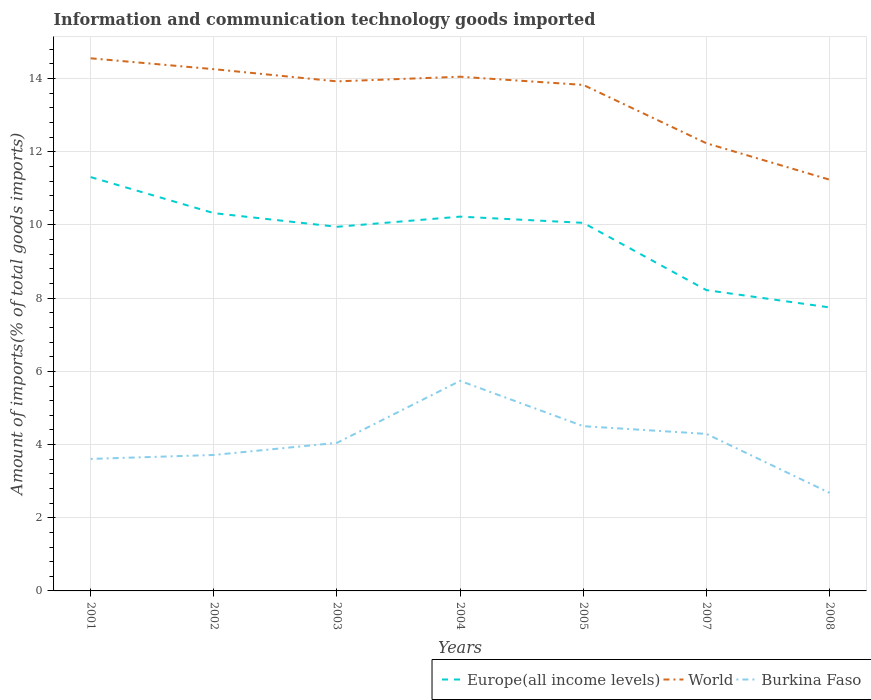Does the line corresponding to Burkina Faso intersect with the line corresponding to World?
Provide a short and direct response. No. Is the number of lines equal to the number of legend labels?
Give a very brief answer. Yes. Across all years, what is the maximum amount of goods imported in World?
Your response must be concise. 11.24. In which year was the amount of goods imported in Europe(all income levels) maximum?
Provide a succinct answer. 2008. What is the total amount of goods imported in Burkina Faso in the graph?
Provide a succinct answer. -0.33. What is the difference between the highest and the second highest amount of goods imported in World?
Offer a very short reply. 3.32. How many years are there in the graph?
Keep it short and to the point. 7. What is the difference between two consecutive major ticks on the Y-axis?
Keep it short and to the point. 2. Are the values on the major ticks of Y-axis written in scientific E-notation?
Offer a very short reply. No. Does the graph contain any zero values?
Your answer should be very brief. No. Where does the legend appear in the graph?
Ensure brevity in your answer.  Bottom right. What is the title of the graph?
Give a very brief answer. Information and communication technology goods imported. Does "Rwanda" appear as one of the legend labels in the graph?
Keep it short and to the point. No. What is the label or title of the Y-axis?
Your response must be concise. Amount of imports(% of total goods imports). What is the Amount of imports(% of total goods imports) of Europe(all income levels) in 2001?
Your answer should be very brief. 11.31. What is the Amount of imports(% of total goods imports) of World in 2001?
Offer a very short reply. 14.56. What is the Amount of imports(% of total goods imports) in Burkina Faso in 2001?
Your response must be concise. 3.61. What is the Amount of imports(% of total goods imports) in Europe(all income levels) in 2002?
Provide a succinct answer. 10.32. What is the Amount of imports(% of total goods imports) of World in 2002?
Make the answer very short. 14.26. What is the Amount of imports(% of total goods imports) of Burkina Faso in 2002?
Provide a succinct answer. 3.72. What is the Amount of imports(% of total goods imports) of Europe(all income levels) in 2003?
Offer a very short reply. 9.95. What is the Amount of imports(% of total goods imports) in World in 2003?
Offer a terse response. 13.92. What is the Amount of imports(% of total goods imports) of Burkina Faso in 2003?
Provide a succinct answer. 4.05. What is the Amount of imports(% of total goods imports) of Europe(all income levels) in 2004?
Keep it short and to the point. 10.23. What is the Amount of imports(% of total goods imports) of World in 2004?
Offer a very short reply. 14.05. What is the Amount of imports(% of total goods imports) of Burkina Faso in 2004?
Your response must be concise. 5.74. What is the Amount of imports(% of total goods imports) of Europe(all income levels) in 2005?
Offer a very short reply. 10.06. What is the Amount of imports(% of total goods imports) of World in 2005?
Provide a short and direct response. 13.83. What is the Amount of imports(% of total goods imports) of Burkina Faso in 2005?
Ensure brevity in your answer.  4.5. What is the Amount of imports(% of total goods imports) of Europe(all income levels) in 2007?
Offer a very short reply. 8.22. What is the Amount of imports(% of total goods imports) in World in 2007?
Ensure brevity in your answer.  12.23. What is the Amount of imports(% of total goods imports) of Burkina Faso in 2007?
Provide a short and direct response. 4.29. What is the Amount of imports(% of total goods imports) of Europe(all income levels) in 2008?
Make the answer very short. 7.75. What is the Amount of imports(% of total goods imports) of World in 2008?
Make the answer very short. 11.24. What is the Amount of imports(% of total goods imports) of Burkina Faso in 2008?
Your answer should be compact. 2.68. Across all years, what is the maximum Amount of imports(% of total goods imports) in Europe(all income levels)?
Your answer should be very brief. 11.31. Across all years, what is the maximum Amount of imports(% of total goods imports) of World?
Your answer should be very brief. 14.56. Across all years, what is the maximum Amount of imports(% of total goods imports) of Burkina Faso?
Your answer should be compact. 5.74. Across all years, what is the minimum Amount of imports(% of total goods imports) in Europe(all income levels)?
Keep it short and to the point. 7.75. Across all years, what is the minimum Amount of imports(% of total goods imports) in World?
Keep it short and to the point. 11.24. Across all years, what is the minimum Amount of imports(% of total goods imports) in Burkina Faso?
Offer a terse response. 2.68. What is the total Amount of imports(% of total goods imports) of Europe(all income levels) in the graph?
Your response must be concise. 67.84. What is the total Amount of imports(% of total goods imports) in World in the graph?
Make the answer very short. 94.09. What is the total Amount of imports(% of total goods imports) of Burkina Faso in the graph?
Offer a terse response. 28.58. What is the difference between the Amount of imports(% of total goods imports) in Europe(all income levels) in 2001 and that in 2002?
Make the answer very short. 0.98. What is the difference between the Amount of imports(% of total goods imports) of World in 2001 and that in 2002?
Your answer should be compact. 0.3. What is the difference between the Amount of imports(% of total goods imports) of Burkina Faso in 2001 and that in 2002?
Your response must be concise. -0.11. What is the difference between the Amount of imports(% of total goods imports) of Europe(all income levels) in 2001 and that in 2003?
Ensure brevity in your answer.  1.36. What is the difference between the Amount of imports(% of total goods imports) in World in 2001 and that in 2003?
Your answer should be very brief. 0.63. What is the difference between the Amount of imports(% of total goods imports) of Burkina Faso in 2001 and that in 2003?
Ensure brevity in your answer.  -0.44. What is the difference between the Amount of imports(% of total goods imports) in Europe(all income levels) in 2001 and that in 2004?
Ensure brevity in your answer.  1.08. What is the difference between the Amount of imports(% of total goods imports) of World in 2001 and that in 2004?
Keep it short and to the point. 0.5. What is the difference between the Amount of imports(% of total goods imports) of Burkina Faso in 2001 and that in 2004?
Offer a very short reply. -2.13. What is the difference between the Amount of imports(% of total goods imports) in Europe(all income levels) in 2001 and that in 2005?
Provide a short and direct response. 1.25. What is the difference between the Amount of imports(% of total goods imports) in World in 2001 and that in 2005?
Provide a succinct answer. 0.73. What is the difference between the Amount of imports(% of total goods imports) in Burkina Faso in 2001 and that in 2005?
Your response must be concise. -0.9. What is the difference between the Amount of imports(% of total goods imports) in Europe(all income levels) in 2001 and that in 2007?
Keep it short and to the point. 3.09. What is the difference between the Amount of imports(% of total goods imports) of World in 2001 and that in 2007?
Your answer should be compact. 2.32. What is the difference between the Amount of imports(% of total goods imports) of Burkina Faso in 2001 and that in 2007?
Provide a succinct answer. -0.68. What is the difference between the Amount of imports(% of total goods imports) in Europe(all income levels) in 2001 and that in 2008?
Make the answer very short. 3.56. What is the difference between the Amount of imports(% of total goods imports) in World in 2001 and that in 2008?
Your answer should be very brief. 3.32. What is the difference between the Amount of imports(% of total goods imports) in Burkina Faso in 2001 and that in 2008?
Make the answer very short. 0.93. What is the difference between the Amount of imports(% of total goods imports) in Europe(all income levels) in 2002 and that in 2003?
Your response must be concise. 0.37. What is the difference between the Amount of imports(% of total goods imports) of World in 2002 and that in 2003?
Your answer should be very brief. 0.33. What is the difference between the Amount of imports(% of total goods imports) in Burkina Faso in 2002 and that in 2003?
Keep it short and to the point. -0.33. What is the difference between the Amount of imports(% of total goods imports) in Europe(all income levels) in 2002 and that in 2004?
Keep it short and to the point. 0.1. What is the difference between the Amount of imports(% of total goods imports) in World in 2002 and that in 2004?
Give a very brief answer. 0.21. What is the difference between the Amount of imports(% of total goods imports) in Burkina Faso in 2002 and that in 2004?
Keep it short and to the point. -2.03. What is the difference between the Amount of imports(% of total goods imports) in Europe(all income levels) in 2002 and that in 2005?
Make the answer very short. 0.27. What is the difference between the Amount of imports(% of total goods imports) in World in 2002 and that in 2005?
Your answer should be very brief. 0.43. What is the difference between the Amount of imports(% of total goods imports) in Burkina Faso in 2002 and that in 2005?
Ensure brevity in your answer.  -0.79. What is the difference between the Amount of imports(% of total goods imports) in Europe(all income levels) in 2002 and that in 2007?
Your response must be concise. 2.1. What is the difference between the Amount of imports(% of total goods imports) in World in 2002 and that in 2007?
Offer a very short reply. 2.02. What is the difference between the Amount of imports(% of total goods imports) in Burkina Faso in 2002 and that in 2007?
Your answer should be very brief. -0.58. What is the difference between the Amount of imports(% of total goods imports) of Europe(all income levels) in 2002 and that in 2008?
Provide a succinct answer. 2.58. What is the difference between the Amount of imports(% of total goods imports) in World in 2002 and that in 2008?
Offer a very short reply. 3.02. What is the difference between the Amount of imports(% of total goods imports) of Burkina Faso in 2002 and that in 2008?
Ensure brevity in your answer.  1.04. What is the difference between the Amount of imports(% of total goods imports) of Europe(all income levels) in 2003 and that in 2004?
Keep it short and to the point. -0.28. What is the difference between the Amount of imports(% of total goods imports) of World in 2003 and that in 2004?
Offer a very short reply. -0.13. What is the difference between the Amount of imports(% of total goods imports) of Burkina Faso in 2003 and that in 2004?
Your answer should be compact. -1.69. What is the difference between the Amount of imports(% of total goods imports) of Europe(all income levels) in 2003 and that in 2005?
Provide a short and direct response. -0.11. What is the difference between the Amount of imports(% of total goods imports) of World in 2003 and that in 2005?
Ensure brevity in your answer.  0.1. What is the difference between the Amount of imports(% of total goods imports) of Burkina Faso in 2003 and that in 2005?
Offer a very short reply. -0.46. What is the difference between the Amount of imports(% of total goods imports) in Europe(all income levels) in 2003 and that in 2007?
Provide a short and direct response. 1.73. What is the difference between the Amount of imports(% of total goods imports) in World in 2003 and that in 2007?
Provide a short and direct response. 1.69. What is the difference between the Amount of imports(% of total goods imports) of Burkina Faso in 2003 and that in 2007?
Offer a terse response. -0.24. What is the difference between the Amount of imports(% of total goods imports) of Europe(all income levels) in 2003 and that in 2008?
Provide a succinct answer. 2.2. What is the difference between the Amount of imports(% of total goods imports) in World in 2003 and that in 2008?
Provide a succinct answer. 2.69. What is the difference between the Amount of imports(% of total goods imports) of Burkina Faso in 2003 and that in 2008?
Give a very brief answer. 1.37. What is the difference between the Amount of imports(% of total goods imports) of Europe(all income levels) in 2004 and that in 2005?
Ensure brevity in your answer.  0.17. What is the difference between the Amount of imports(% of total goods imports) of World in 2004 and that in 2005?
Provide a short and direct response. 0.22. What is the difference between the Amount of imports(% of total goods imports) of Burkina Faso in 2004 and that in 2005?
Your response must be concise. 1.24. What is the difference between the Amount of imports(% of total goods imports) of Europe(all income levels) in 2004 and that in 2007?
Your answer should be compact. 2.01. What is the difference between the Amount of imports(% of total goods imports) in World in 2004 and that in 2007?
Provide a short and direct response. 1.82. What is the difference between the Amount of imports(% of total goods imports) in Burkina Faso in 2004 and that in 2007?
Ensure brevity in your answer.  1.45. What is the difference between the Amount of imports(% of total goods imports) in Europe(all income levels) in 2004 and that in 2008?
Offer a terse response. 2.48. What is the difference between the Amount of imports(% of total goods imports) of World in 2004 and that in 2008?
Keep it short and to the point. 2.81. What is the difference between the Amount of imports(% of total goods imports) in Burkina Faso in 2004 and that in 2008?
Your answer should be very brief. 3.06. What is the difference between the Amount of imports(% of total goods imports) of Europe(all income levels) in 2005 and that in 2007?
Ensure brevity in your answer.  1.84. What is the difference between the Amount of imports(% of total goods imports) of World in 2005 and that in 2007?
Provide a short and direct response. 1.59. What is the difference between the Amount of imports(% of total goods imports) of Burkina Faso in 2005 and that in 2007?
Offer a terse response. 0.21. What is the difference between the Amount of imports(% of total goods imports) in Europe(all income levels) in 2005 and that in 2008?
Give a very brief answer. 2.31. What is the difference between the Amount of imports(% of total goods imports) of World in 2005 and that in 2008?
Provide a succinct answer. 2.59. What is the difference between the Amount of imports(% of total goods imports) of Burkina Faso in 2005 and that in 2008?
Offer a very short reply. 1.82. What is the difference between the Amount of imports(% of total goods imports) in Europe(all income levels) in 2007 and that in 2008?
Ensure brevity in your answer.  0.47. What is the difference between the Amount of imports(% of total goods imports) in World in 2007 and that in 2008?
Offer a very short reply. 0.99. What is the difference between the Amount of imports(% of total goods imports) in Burkina Faso in 2007 and that in 2008?
Your answer should be very brief. 1.61. What is the difference between the Amount of imports(% of total goods imports) of Europe(all income levels) in 2001 and the Amount of imports(% of total goods imports) of World in 2002?
Provide a succinct answer. -2.95. What is the difference between the Amount of imports(% of total goods imports) of Europe(all income levels) in 2001 and the Amount of imports(% of total goods imports) of Burkina Faso in 2002?
Ensure brevity in your answer.  7.59. What is the difference between the Amount of imports(% of total goods imports) in World in 2001 and the Amount of imports(% of total goods imports) in Burkina Faso in 2002?
Provide a succinct answer. 10.84. What is the difference between the Amount of imports(% of total goods imports) of Europe(all income levels) in 2001 and the Amount of imports(% of total goods imports) of World in 2003?
Give a very brief answer. -2.62. What is the difference between the Amount of imports(% of total goods imports) in Europe(all income levels) in 2001 and the Amount of imports(% of total goods imports) in Burkina Faso in 2003?
Ensure brevity in your answer.  7.26. What is the difference between the Amount of imports(% of total goods imports) of World in 2001 and the Amount of imports(% of total goods imports) of Burkina Faso in 2003?
Offer a very short reply. 10.51. What is the difference between the Amount of imports(% of total goods imports) of Europe(all income levels) in 2001 and the Amount of imports(% of total goods imports) of World in 2004?
Your answer should be very brief. -2.74. What is the difference between the Amount of imports(% of total goods imports) in Europe(all income levels) in 2001 and the Amount of imports(% of total goods imports) in Burkina Faso in 2004?
Your response must be concise. 5.57. What is the difference between the Amount of imports(% of total goods imports) of World in 2001 and the Amount of imports(% of total goods imports) of Burkina Faso in 2004?
Offer a terse response. 8.81. What is the difference between the Amount of imports(% of total goods imports) of Europe(all income levels) in 2001 and the Amount of imports(% of total goods imports) of World in 2005?
Your response must be concise. -2.52. What is the difference between the Amount of imports(% of total goods imports) of Europe(all income levels) in 2001 and the Amount of imports(% of total goods imports) of Burkina Faso in 2005?
Your answer should be very brief. 6.81. What is the difference between the Amount of imports(% of total goods imports) of World in 2001 and the Amount of imports(% of total goods imports) of Burkina Faso in 2005?
Offer a terse response. 10.05. What is the difference between the Amount of imports(% of total goods imports) in Europe(all income levels) in 2001 and the Amount of imports(% of total goods imports) in World in 2007?
Offer a very short reply. -0.92. What is the difference between the Amount of imports(% of total goods imports) of Europe(all income levels) in 2001 and the Amount of imports(% of total goods imports) of Burkina Faso in 2007?
Make the answer very short. 7.02. What is the difference between the Amount of imports(% of total goods imports) of World in 2001 and the Amount of imports(% of total goods imports) of Burkina Faso in 2007?
Your answer should be very brief. 10.26. What is the difference between the Amount of imports(% of total goods imports) of Europe(all income levels) in 2001 and the Amount of imports(% of total goods imports) of World in 2008?
Give a very brief answer. 0.07. What is the difference between the Amount of imports(% of total goods imports) of Europe(all income levels) in 2001 and the Amount of imports(% of total goods imports) of Burkina Faso in 2008?
Your answer should be compact. 8.63. What is the difference between the Amount of imports(% of total goods imports) in World in 2001 and the Amount of imports(% of total goods imports) in Burkina Faso in 2008?
Make the answer very short. 11.88. What is the difference between the Amount of imports(% of total goods imports) of Europe(all income levels) in 2002 and the Amount of imports(% of total goods imports) of World in 2003?
Ensure brevity in your answer.  -3.6. What is the difference between the Amount of imports(% of total goods imports) of Europe(all income levels) in 2002 and the Amount of imports(% of total goods imports) of Burkina Faso in 2003?
Provide a succinct answer. 6.28. What is the difference between the Amount of imports(% of total goods imports) of World in 2002 and the Amount of imports(% of total goods imports) of Burkina Faso in 2003?
Give a very brief answer. 10.21. What is the difference between the Amount of imports(% of total goods imports) in Europe(all income levels) in 2002 and the Amount of imports(% of total goods imports) in World in 2004?
Ensure brevity in your answer.  -3.73. What is the difference between the Amount of imports(% of total goods imports) in Europe(all income levels) in 2002 and the Amount of imports(% of total goods imports) in Burkina Faso in 2004?
Make the answer very short. 4.58. What is the difference between the Amount of imports(% of total goods imports) of World in 2002 and the Amount of imports(% of total goods imports) of Burkina Faso in 2004?
Make the answer very short. 8.52. What is the difference between the Amount of imports(% of total goods imports) of Europe(all income levels) in 2002 and the Amount of imports(% of total goods imports) of World in 2005?
Make the answer very short. -3.5. What is the difference between the Amount of imports(% of total goods imports) of Europe(all income levels) in 2002 and the Amount of imports(% of total goods imports) of Burkina Faso in 2005?
Provide a succinct answer. 5.82. What is the difference between the Amount of imports(% of total goods imports) of World in 2002 and the Amount of imports(% of total goods imports) of Burkina Faso in 2005?
Keep it short and to the point. 9.76. What is the difference between the Amount of imports(% of total goods imports) of Europe(all income levels) in 2002 and the Amount of imports(% of total goods imports) of World in 2007?
Keep it short and to the point. -1.91. What is the difference between the Amount of imports(% of total goods imports) of Europe(all income levels) in 2002 and the Amount of imports(% of total goods imports) of Burkina Faso in 2007?
Offer a terse response. 6.03. What is the difference between the Amount of imports(% of total goods imports) in World in 2002 and the Amount of imports(% of total goods imports) in Burkina Faso in 2007?
Provide a succinct answer. 9.97. What is the difference between the Amount of imports(% of total goods imports) of Europe(all income levels) in 2002 and the Amount of imports(% of total goods imports) of World in 2008?
Provide a short and direct response. -0.91. What is the difference between the Amount of imports(% of total goods imports) of Europe(all income levels) in 2002 and the Amount of imports(% of total goods imports) of Burkina Faso in 2008?
Your response must be concise. 7.64. What is the difference between the Amount of imports(% of total goods imports) of World in 2002 and the Amount of imports(% of total goods imports) of Burkina Faso in 2008?
Give a very brief answer. 11.58. What is the difference between the Amount of imports(% of total goods imports) of Europe(all income levels) in 2003 and the Amount of imports(% of total goods imports) of World in 2004?
Make the answer very short. -4.1. What is the difference between the Amount of imports(% of total goods imports) in Europe(all income levels) in 2003 and the Amount of imports(% of total goods imports) in Burkina Faso in 2004?
Ensure brevity in your answer.  4.21. What is the difference between the Amount of imports(% of total goods imports) of World in 2003 and the Amount of imports(% of total goods imports) of Burkina Faso in 2004?
Keep it short and to the point. 8.18. What is the difference between the Amount of imports(% of total goods imports) of Europe(all income levels) in 2003 and the Amount of imports(% of total goods imports) of World in 2005?
Provide a short and direct response. -3.88. What is the difference between the Amount of imports(% of total goods imports) in Europe(all income levels) in 2003 and the Amount of imports(% of total goods imports) in Burkina Faso in 2005?
Offer a very short reply. 5.45. What is the difference between the Amount of imports(% of total goods imports) of World in 2003 and the Amount of imports(% of total goods imports) of Burkina Faso in 2005?
Provide a short and direct response. 9.42. What is the difference between the Amount of imports(% of total goods imports) of Europe(all income levels) in 2003 and the Amount of imports(% of total goods imports) of World in 2007?
Provide a short and direct response. -2.28. What is the difference between the Amount of imports(% of total goods imports) in Europe(all income levels) in 2003 and the Amount of imports(% of total goods imports) in Burkina Faso in 2007?
Offer a very short reply. 5.66. What is the difference between the Amount of imports(% of total goods imports) in World in 2003 and the Amount of imports(% of total goods imports) in Burkina Faso in 2007?
Your answer should be compact. 9.63. What is the difference between the Amount of imports(% of total goods imports) of Europe(all income levels) in 2003 and the Amount of imports(% of total goods imports) of World in 2008?
Offer a very short reply. -1.29. What is the difference between the Amount of imports(% of total goods imports) in Europe(all income levels) in 2003 and the Amount of imports(% of total goods imports) in Burkina Faso in 2008?
Your response must be concise. 7.27. What is the difference between the Amount of imports(% of total goods imports) of World in 2003 and the Amount of imports(% of total goods imports) of Burkina Faso in 2008?
Offer a very short reply. 11.24. What is the difference between the Amount of imports(% of total goods imports) of Europe(all income levels) in 2004 and the Amount of imports(% of total goods imports) of World in 2005?
Provide a succinct answer. -3.6. What is the difference between the Amount of imports(% of total goods imports) in Europe(all income levels) in 2004 and the Amount of imports(% of total goods imports) in Burkina Faso in 2005?
Your answer should be compact. 5.73. What is the difference between the Amount of imports(% of total goods imports) in World in 2004 and the Amount of imports(% of total goods imports) in Burkina Faso in 2005?
Offer a terse response. 9.55. What is the difference between the Amount of imports(% of total goods imports) in Europe(all income levels) in 2004 and the Amount of imports(% of total goods imports) in World in 2007?
Your answer should be very brief. -2. What is the difference between the Amount of imports(% of total goods imports) in Europe(all income levels) in 2004 and the Amount of imports(% of total goods imports) in Burkina Faso in 2007?
Ensure brevity in your answer.  5.94. What is the difference between the Amount of imports(% of total goods imports) of World in 2004 and the Amount of imports(% of total goods imports) of Burkina Faso in 2007?
Your answer should be very brief. 9.76. What is the difference between the Amount of imports(% of total goods imports) in Europe(all income levels) in 2004 and the Amount of imports(% of total goods imports) in World in 2008?
Keep it short and to the point. -1.01. What is the difference between the Amount of imports(% of total goods imports) in Europe(all income levels) in 2004 and the Amount of imports(% of total goods imports) in Burkina Faso in 2008?
Keep it short and to the point. 7.55. What is the difference between the Amount of imports(% of total goods imports) in World in 2004 and the Amount of imports(% of total goods imports) in Burkina Faso in 2008?
Ensure brevity in your answer.  11.37. What is the difference between the Amount of imports(% of total goods imports) of Europe(all income levels) in 2005 and the Amount of imports(% of total goods imports) of World in 2007?
Provide a short and direct response. -2.17. What is the difference between the Amount of imports(% of total goods imports) in Europe(all income levels) in 2005 and the Amount of imports(% of total goods imports) in Burkina Faso in 2007?
Provide a succinct answer. 5.77. What is the difference between the Amount of imports(% of total goods imports) of World in 2005 and the Amount of imports(% of total goods imports) of Burkina Faso in 2007?
Keep it short and to the point. 9.54. What is the difference between the Amount of imports(% of total goods imports) of Europe(all income levels) in 2005 and the Amount of imports(% of total goods imports) of World in 2008?
Ensure brevity in your answer.  -1.18. What is the difference between the Amount of imports(% of total goods imports) in Europe(all income levels) in 2005 and the Amount of imports(% of total goods imports) in Burkina Faso in 2008?
Ensure brevity in your answer.  7.38. What is the difference between the Amount of imports(% of total goods imports) of World in 2005 and the Amount of imports(% of total goods imports) of Burkina Faso in 2008?
Make the answer very short. 11.15. What is the difference between the Amount of imports(% of total goods imports) in Europe(all income levels) in 2007 and the Amount of imports(% of total goods imports) in World in 2008?
Provide a short and direct response. -3.02. What is the difference between the Amount of imports(% of total goods imports) in Europe(all income levels) in 2007 and the Amount of imports(% of total goods imports) in Burkina Faso in 2008?
Keep it short and to the point. 5.54. What is the difference between the Amount of imports(% of total goods imports) of World in 2007 and the Amount of imports(% of total goods imports) of Burkina Faso in 2008?
Ensure brevity in your answer.  9.55. What is the average Amount of imports(% of total goods imports) in Europe(all income levels) per year?
Make the answer very short. 9.69. What is the average Amount of imports(% of total goods imports) of World per year?
Keep it short and to the point. 13.44. What is the average Amount of imports(% of total goods imports) of Burkina Faso per year?
Make the answer very short. 4.08. In the year 2001, what is the difference between the Amount of imports(% of total goods imports) in Europe(all income levels) and Amount of imports(% of total goods imports) in World?
Provide a short and direct response. -3.25. In the year 2001, what is the difference between the Amount of imports(% of total goods imports) in Europe(all income levels) and Amount of imports(% of total goods imports) in Burkina Faso?
Give a very brief answer. 7.7. In the year 2001, what is the difference between the Amount of imports(% of total goods imports) of World and Amount of imports(% of total goods imports) of Burkina Faso?
Provide a succinct answer. 10.95. In the year 2002, what is the difference between the Amount of imports(% of total goods imports) in Europe(all income levels) and Amount of imports(% of total goods imports) in World?
Make the answer very short. -3.93. In the year 2002, what is the difference between the Amount of imports(% of total goods imports) of Europe(all income levels) and Amount of imports(% of total goods imports) of Burkina Faso?
Provide a short and direct response. 6.61. In the year 2002, what is the difference between the Amount of imports(% of total goods imports) in World and Amount of imports(% of total goods imports) in Burkina Faso?
Your answer should be compact. 10.54. In the year 2003, what is the difference between the Amount of imports(% of total goods imports) in Europe(all income levels) and Amount of imports(% of total goods imports) in World?
Ensure brevity in your answer.  -3.97. In the year 2003, what is the difference between the Amount of imports(% of total goods imports) of Europe(all income levels) and Amount of imports(% of total goods imports) of Burkina Faso?
Ensure brevity in your answer.  5.9. In the year 2003, what is the difference between the Amount of imports(% of total goods imports) in World and Amount of imports(% of total goods imports) in Burkina Faso?
Your answer should be very brief. 9.88. In the year 2004, what is the difference between the Amount of imports(% of total goods imports) of Europe(all income levels) and Amount of imports(% of total goods imports) of World?
Offer a terse response. -3.82. In the year 2004, what is the difference between the Amount of imports(% of total goods imports) of Europe(all income levels) and Amount of imports(% of total goods imports) of Burkina Faso?
Offer a very short reply. 4.49. In the year 2004, what is the difference between the Amount of imports(% of total goods imports) of World and Amount of imports(% of total goods imports) of Burkina Faso?
Offer a very short reply. 8.31. In the year 2005, what is the difference between the Amount of imports(% of total goods imports) of Europe(all income levels) and Amount of imports(% of total goods imports) of World?
Give a very brief answer. -3.77. In the year 2005, what is the difference between the Amount of imports(% of total goods imports) in Europe(all income levels) and Amount of imports(% of total goods imports) in Burkina Faso?
Offer a very short reply. 5.56. In the year 2005, what is the difference between the Amount of imports(% of total goods imports) in World and Amount of imports(% of total goods imports) in Burkina Faso?
Your answer should be very brief. 9.33. In the year 2007, what is the difference between the Amount of imports(% of total goods imports) of Europe(all income levels) and Amount of imports(% of total goods imports) of World?
Make the answer very short. -4.01. In the year 2007, what is the difference between the Amount of imports(% of total goods imports) of Europe(all income levels) and Amount of imports(% of total goods imports) of Burkina Faso?
Ensure brevity in your answer.  3.93. In the year 2007, what is the difference between the Amount of imports(% of total goods imports) of World and Amount of imports(% of total goods imports) of Burkina Faso?
Keep it short and to the point. 7.94. In the year 2008, what is the difference between the Amount of imports(% of total goods imports) of Europe(all income levels) and Amount of imports(% of total goods imports) of World?
Your answer should be very brief. -3.49. In the year 2008, what is the difference between the Amount of imports(% of total goods imports) in Europe(all income levels) and Amount of imports(% of total goods imports) in Burkina Faso?
Your response must be concise. 5.07. In the year 2008, what is the difference between the Amount of imports(% of total goods imports) in World and Amount of imports(% of total goods imports) in Burkina Faso?
Your answer should be compact. 8.56. What is the ratio of the Amount of imports(% of total goods imports) in Europe(all income levels) in 2001 to that in 2002?
Your answer should be very brief. 1.1. What is the ratio of the Amount of imports(% of total goods imports) in World in 2001 to that in 2002?
Your response must be concise. 1.02. What is the ratio of the Amount of imports(% of total goods imports) of Burkina Faso in 2001 to that in 2002?
Offer a terse response. 0.97. What is the ratio of the Amount of imports(% of total goods imports) in Europe(all income levels) in 2001 to that in 2003?
Provide a succinct answer. 1.14. What is the ratio of the Amount of imports(% of total goods imports) of World in 2001 to that in 2003?
Give a very brief answer. 1.05. What is the ratio of the Amount of imports(% of total goods imports) of Burkina Faso in 2001 to that in 2003?
Make the answer very short. 0.89. What is the ratio of the Amount of imports(% of total goods imports) in Europe(all income levels) in 2001 to that in 2004?
Provide a succinct answer. 1.11. What is the ratio of the Amount of imports(% of total goods imports) of World in 2001 to that in 2004?
Make the answer very short. 1.04. What is the ratio of the Amount of imports(% of total goods imports) of Burkina Faso in 2001 to that in 2004?
Make the answer very short. 0.63. What is the ratio of the Amount of imports(% of total goods imports) of Europe(all income levels) in 2001 to that in 2005?
Give a very brief answer. 1.12. What is the ratio of the Amount of imports(% of total goods imports) of World in 2001 to that in 2005?
Provide a short and direct response. 1.05. What is the ratio of the Amount of imports(% of total goods imports) in Burkina Faso in 2001 to that in 2005?
Provide a succinct answer. 0.8. What is the ratio of the Amount of imports(% of total goods imports) in Europe(all income levels) in 2001 to that in 2007?
Your response must be concise. 1.38. What is the ratio of the Amount of imports(% of total goods imports) in World in 2001 to that in 2007?
Offer a terse response. 1.19. What is the ratio of the Amount of imports(% of total goods imports) of Burkina Faso in 2001 to that in 2007?
Provide a short and direct response. 0.84. What is the ratio of the Amount of imports(% of total goods imports) in Europe(all income levels) in 2001 to that in 2008?
Keep it short and to the point. 1.46. What is the ratio of the Amount of imports(% of total goods imports) in World in 2001 to that in 2008?
Your answer should be very brief. 1.3. What is the ratio of the Amount of imports(% of total goods imports) of Burkina Faso in 2001 to that in 2008?
Provide a short and direct response. 1.35. What is the ratio of the Amount of imports(% of total goods imports) of Europe(all income levels) in 2002 to that in 2003?
Offer a terse response. 1.04. What is the ratio of the Amount of imports(% of total goods imports) in World in 2002 to that in 2003?
Give a very brief answer. 1.02. What is the ratio of the Amount of imports(% of total goods imports) of Burkina Faso in 2002 to that in 2003?
Your response must be concise. 0.92. What is the ratio of the Amount of imports(% of total goods imports) in Europe(all income levels) in 2002 to that in 2004?
Offer a very short reply. 1.01. What is the ratio of the Amount of imports(% of total goods imports) of World in 2002 to that in 2004?
Provide a succinct answer. 1.01. What is the ratio of the Amount of imports(% of total goods imports) of Burkina Faso in 2002 to that in 2004?
Offer a very short reply. 0.65. What is the ratio of the Amount of imports(% of total goods imports) of Europe(all income levels) in 2002 to that in 2005?
Make the answer very short. 1.03. What is the ratio of the Amount of imports(% of total goods imports) in World in 2002 to that in 2005?
Give a very brief answer. 1.03. What is the ratio of the Amount of imports(% of total goods imports) in Burkina Faso in 2002 to that in 2005?
Make the answer very short. 0.83. What is the ratio of the Amount of imports(% of total goods imports) of Europe(all income levels) in 2002 to that in 2007?
Your answer should be compact. 1.26. What is the ratio of the Amount of imports(% of total goods imports) of World in 2002 to that in 2007?
Offer a terse response. 1.17. What is the ratio of the Amount of imports(% of total goods imports) in Burkina Faso in 2002 to that in 2007?
Your response must be concise. 0.87. What is the ratio of the Amount of imports(% of total goods imports) in Europe(all income levels) in 2002 to that in 2008?
Provide a short and direct response. 1.33. What is the ratio of the Amount of imports(% of total goods imports) in World in 2002 to that in 2008?
Offer a terse response. 1.27. What is the ratio of the Amount of imports(% of total goods imports) of Burkina Faso in 2002 to that in 2008?
Make the answer very short. 1.39. What is the ratio of the Amount of imports(% of total goods imports) in Europe(all income levels) in 2003 to that in 2004?
Your answer should be compact. 0.97. What is the ratio of the Amount of imports(% of total goods imports) in Burkina Faso in 2003 to that in 2004?
Offer a terse response. 0.7. What is the ratio of the Amount of imports(% of total goods imports) in Europe(all income levels) in 2003 to that in 2005?
Your answer should be compact. 0.99. What is the ratio of the Amount of imports(% of total goods imports) in Burkina Faso in 2003 to that in 2005?
Your response must be concise. 0.9. What is the ratio of the Amount of imports(% of total goods imports) of Europe(all income levels) in 2003 to that in 2007?
Give a very brief answer. 1.21. What is the ratio of the Amount of imports(% of total goods imports) in World in 2003 to that in 2007?
Offer a terse response. 1.14. What is the ratio of the Amount of imports(% of total goods imports) in Burkina Faso in 2003 to that in 2007?
Offer a terse response. 0.94. What is the ratio of the Amount of imports(% of total goods imports) of Europe(all income levels) in 2003 to that in 2008?
Give a very brief answer. 1.28. What is the ratio of the Amount of imports(% of total goods imports) in World in 2003 to that in 2008?
Give a very brief answer. 1.24. What is the ratio of the Amount of imports(% of total goods imports) in Burkina Faso in 2003 to that in 2008?
Your answer should be compact. 1.51. What is the ratio of the Amount of imports(% of total goods imports) of Europe(all income levels) in 2004 to that in 2005?
Provide a short and direct response. 1.02. What is the ratio of the Amount of imports(% of total goods imports) of World in 2004 to that in 2005?
Give a very brief answer. 1.02. What is the ratio of the Amount of imports(% of total goods imports) in Burkina Faso in 2004 to that in 2005?
Give a very brief answer. 1.27. What is the ratio of the Amount of imports(% of total goods imports) of Europe(all income levels) in 2004 to that in 2007?
Offer a terse response. 1.24. What is the ratio of the Amount of imports(% of total goods imports) in World in 2004 to that in 2007?
Keep it short and to the point. 1.15. What is the ratio of the Amount of imports(% of total goods imports) of Burkina Faso in 2004 to that in 2007?
Your answer should be very brief. 1.34. What is the ratio of the Amount of imports(% of total goods imports) in Europe(all income levels) in 2004 to that in 2008?
Make the answer very short. 1.32. What is the ratio of the Amount of imports(% of total goods imports) in World in 2004 to that in 2008?
Offer a very short reply. 1.25. What is the ratio of the Amount of imports(% of total goods imports) of Burkina Faso in 2004 to that in 2008?
Provide a succinct answer. 2.14. What is the ratio of the Amount of imports(% of total goods imports) in Europe(all income levels) in 2005 to that in 2007?
Your answer should be very brief. 1.22. What is the ratio of the Amount of imports(% of total goods imports) of World in 2005 to that in 2007?
Your answer should be compact. 1.13. What is the ratio of the Amount of imports(% of total goods imports) in Burkina Faso in 2005 to that in 2007?
Offer a very short reply. 1.05. What is the ratio of the Amount of imports(% of total goods imports) of Europe(all income levels) in 2005 to that in 2008?
Provide a short and direct response. 1.3. What is the ratio of the Amount of imports(% of total goods imports) in World in 2005 to that in 2008?
Offer a terse response. 1.23. What is the ratio of the Amount of imports(% of total goods imports) of Burkina Faso in 2005 to that in 2008?
Your answer should be compact. 1.68. What is the ratio of the Amount of imports(% of total goods imports) in Europe(all income levels) in 2007 to that in 2008?
Offer a terse response. 1.06. What is the ratio of the Amount of imports(% of total goods imports) in World in 2007 to that in 2008?
Provide a short and direct response. 1.09. What is the ratio of the Amount of imports(% of total goods imports) in Burkina Faso in 2007 to that in 2008?
Give a very brief answer. 1.6. What is the difference between the highest and the second highest Amount of imports(% of total goods imports) of World?
Offer a very short reply. 0.3. What is the difference between the highest and the second highest Amount of imports(% of total goods imports) of Burkina Faso?
Keep it short and to the point. 1.24. What is the difference between the highest and the lowest Amount of imports(% of total goods imports) of Europe(all income levels)?
Keep it short and to the point. 3.56. What is the difference between the highest and the lowest Amount of imports(% of total goods imports) in World?
Your answer should be very brief. 3.32. What is the difference between the highest and the lowest Amount of imports(% of total goods imports) of Burkina Faso?
Offer a terse response. 3.06. 